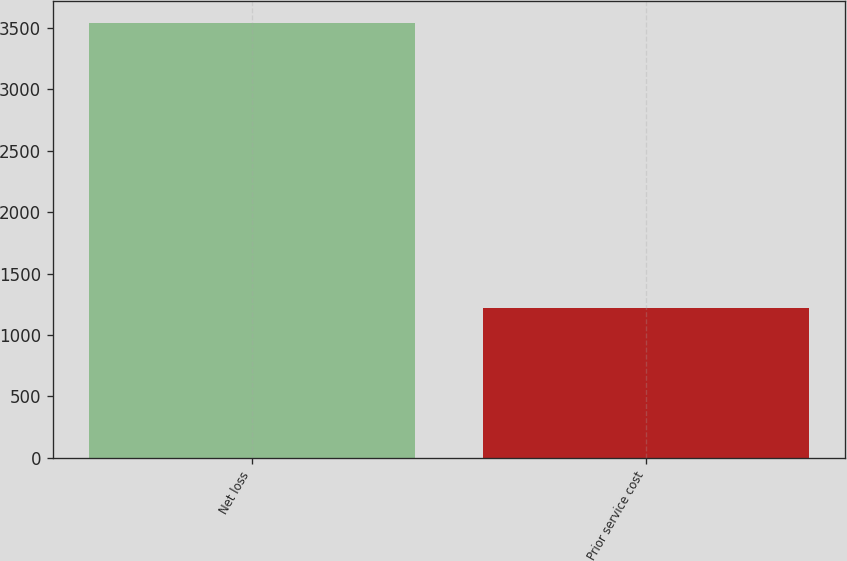Convert chart to OTSL. <chart><loc_0><loc_0><loc_500><loc_500><bar_chart><fcel>Net loss<fcel>Prior service cost<nl><fcel>3539<fcel>1220<nl></chart> 